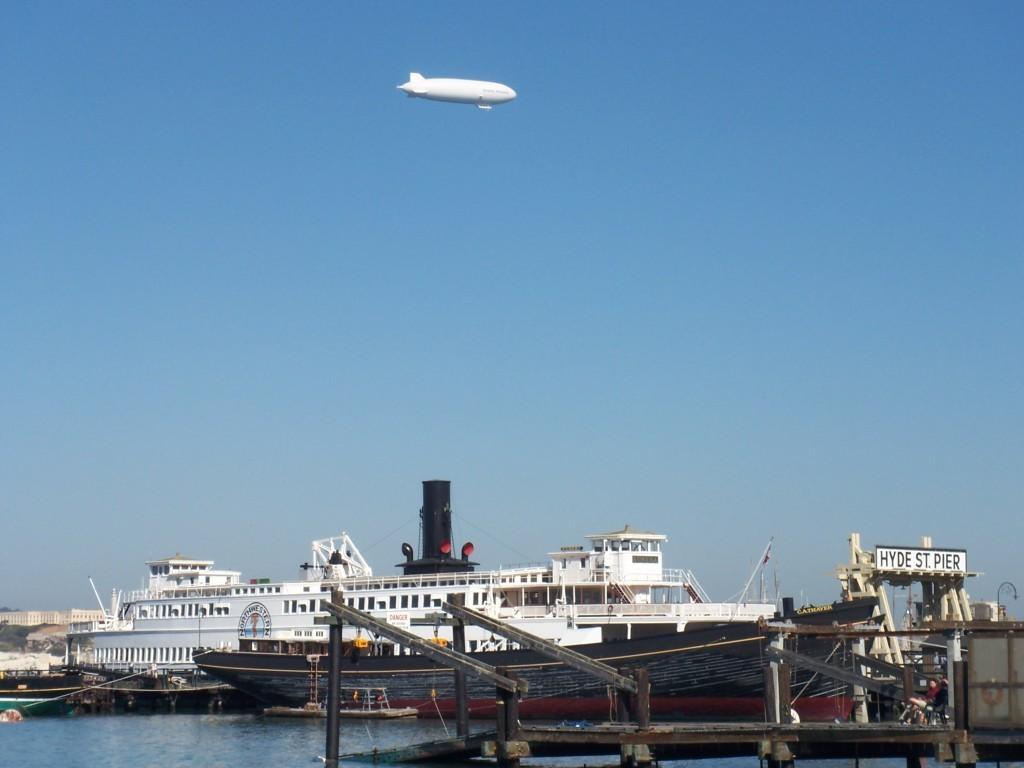Please provide a concise description of this image. This picture shows a ship in the water and we see a air balloon and a blue sky and couple of boats in the water and we see buildings. 